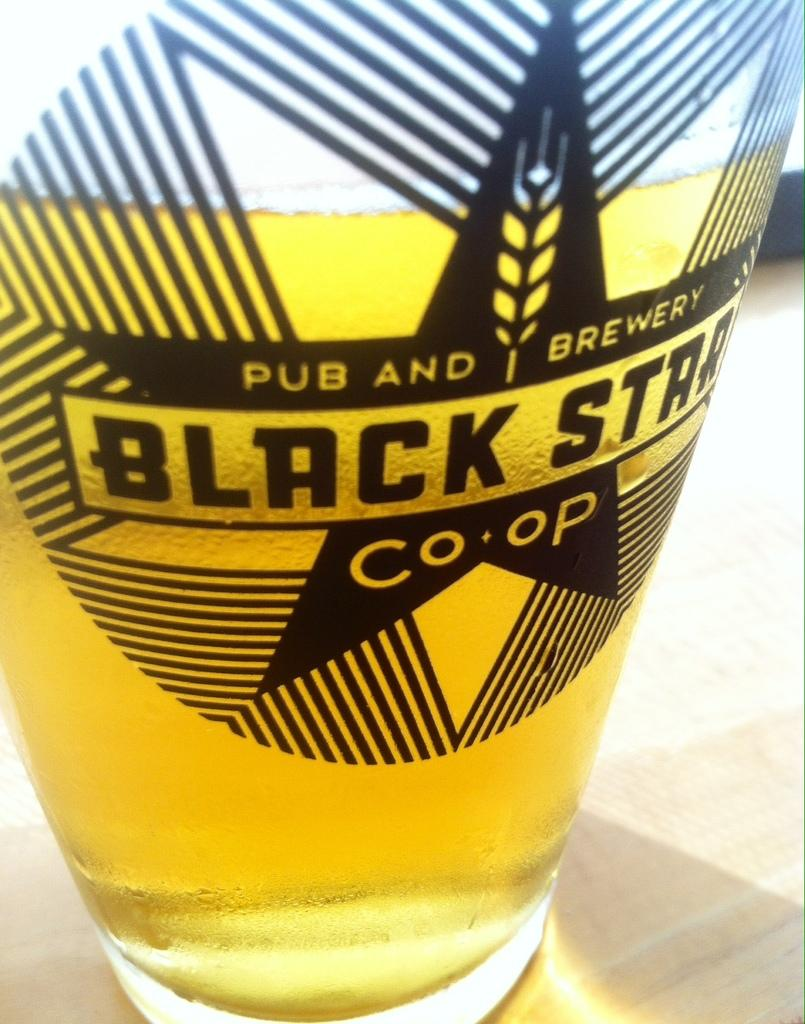<image>
Present a compact description of the photo's key features. A glass of beer is decorated with the Black Star logo. 